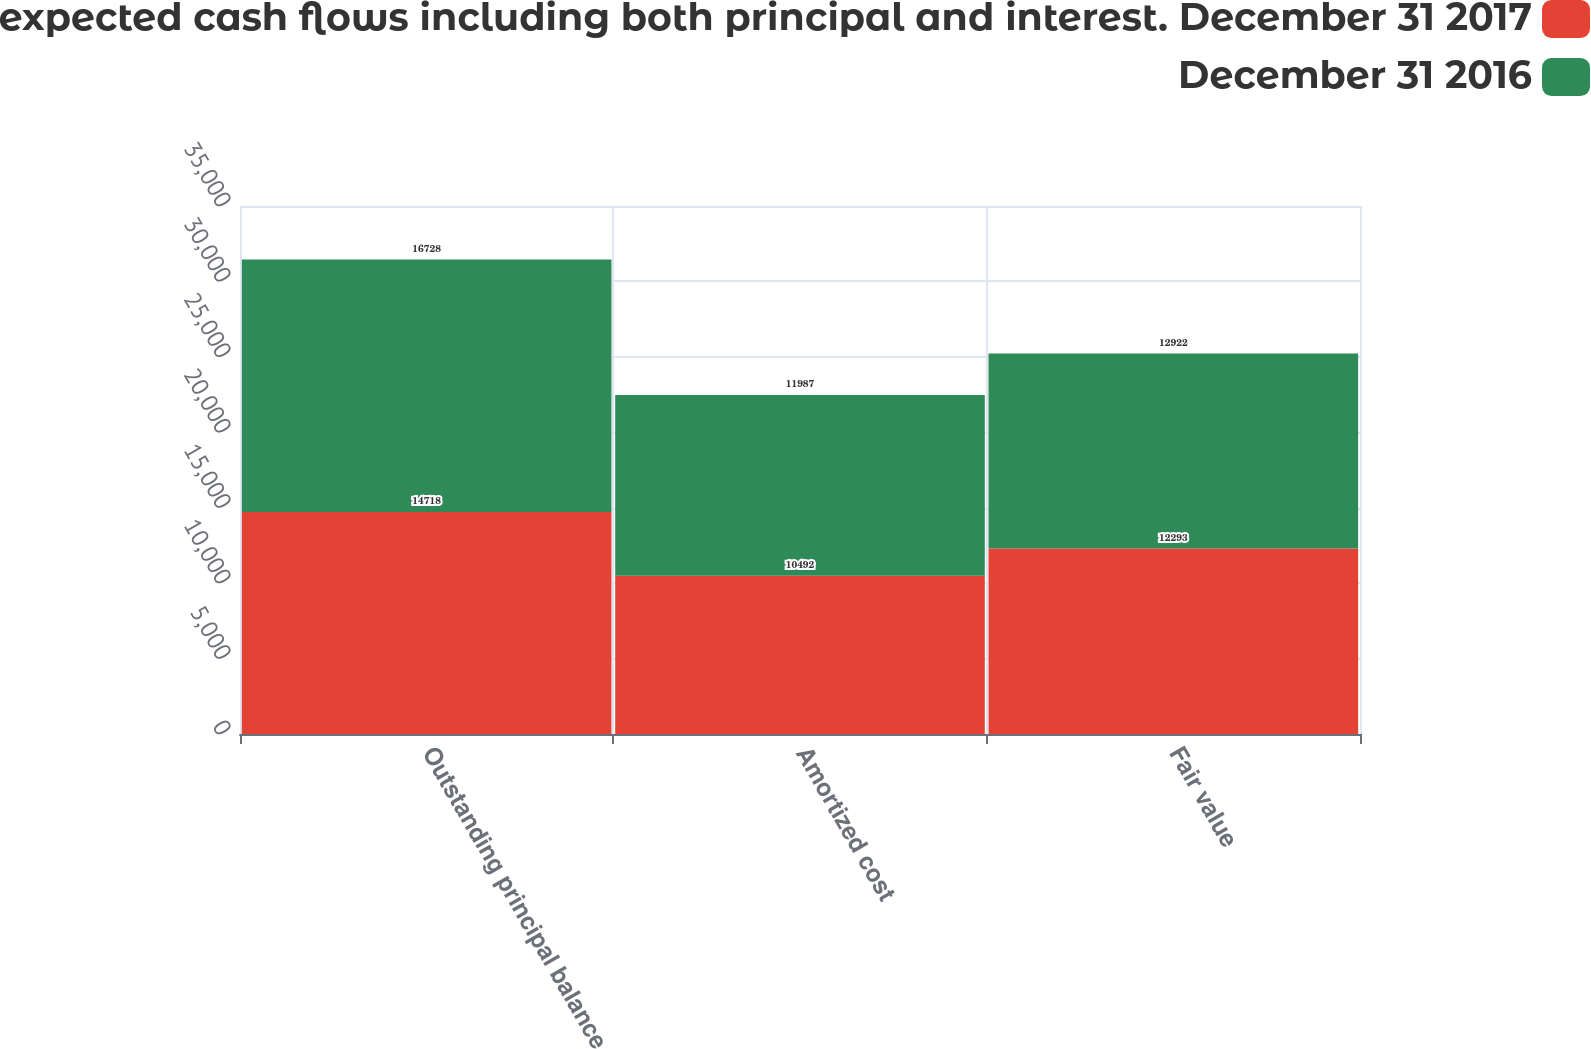<chart> <loc_0><loc_0><loc_500><loc_500><stacked_bar_chart><ecel><fcel>Outstanding principal balance<fcel>Amortized cost<fcel>Fair value<nl><fcel>Represents undiscounted expected cash flows including both principal and interest. December 31 2017<fcel>14718<fcel>10492<fcel>12293<nl><fcel>December 31 2016<fcel>16728<fcel>11987<fcel>12922<nl></chart> 